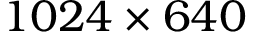<formula> <loc_0><loc_0><loc_500><loc_500>1 0 2 4 \times 6 4 0</formula> 